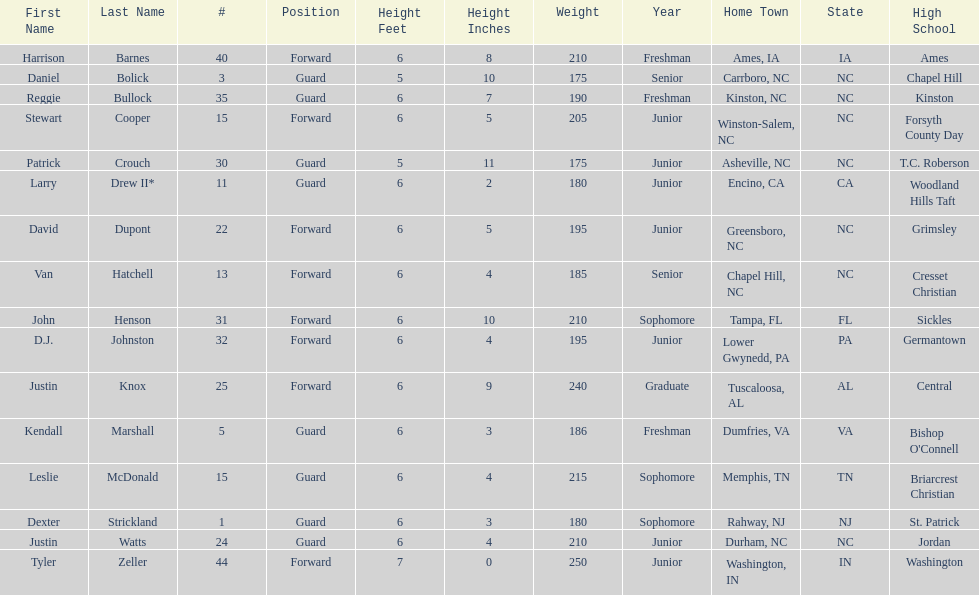How many players play a position other than guard? 8. Write the full table. {'header': ['First Name', 'Last Name', '#', 'Position', 'Height Feet', 'Height Inches', 'Weight', 'Year', 'Home Town', 'State', 'High School'], 'rows': [['Harrison', 'Barnes', '40', 'Forward', '6', '8', '210', 'Freshman', 'Ames, IA', 'IA', 'Ames'], ['Daniel', 'Bolick', '3', 'Guard', '5', '10', '175', 'Senior', 'Carrboro, NC', 'NC', 'Chapel Hill'], ['Reggie', 'Bullock', '35', 'Guard', '6', '7', '190', 'Freshman', 'Kinston, NC', 'NC', 'Kinston'], ['Stewart', 'Cooper', '15', 'Forward', '6', '5', '205', 'Junior', 'Winston-Salem, NC', 'NC', 'Forsyth County Day'], ['Patrick', 'Crouch', '30', 'Guard', '5', '11', '175', 'Junior', 'Asheville, NC', 'NC', 'T.C. Roberson'], ['Larry', 'Drew II*', '11', 'Guard', '6', '2', '180', 'Junior', 'Encino, CA', 'CA', 'Woodland Hills Taft'], ['David', 'Dupont', '22', 'Forward', '6', '5', '195', 'Junior', 'Greensboro, NC', 'NC', 'Grimsley'], ['Van', 'Hatchell', '13', 'Forward', '6', '4', '185', 'Senior', 'Chapel Hill, NC', 'NC', 'Cresset Christian'], ['John', 'Henson', '31', 'Forward', '6', '10', '210', 'Sophomore', 'Tampa, FL', 'FL', 'Sickles'], ['D.J.', 'Johnston', '32', 'Forward', '6', '4', '195', 'Junior', 'Lower Gwynedd, PA', 'PA', 'Germantown'], ['Justin', 'Knox', '25', 'Forward', '6', '9', '240', 'Graduate', 'Tuscaloosa, AL', 'AL', 'Central'], ['Kendall', 'Marshall', '5', 'Guard', '6', '3', '186', 'Freshman', 'Dumfries, VA', 'VA', "Bishop O'Connell"], ['Leslie', 'McDonald', '15', 'Guard', '6', '4', '215', 'Sophomore', 'Memphis, TN', 'TN', 'Briarcrest Christian'], ['Dexter', 'Strickland', '1', 'Guard', '6', '3', '180', 'Sophomore', 'Rahway, NJ', 'NJ', 'St. Patrick'], ['Justin', 'Watts', '24', 'Guard', '6', '4', '210', 'Junior', 'Durham, NC', 'NC', 'Jordan'], ['Tyler', 'Zeller', '44', 'Forward', '7', '0', '250', 'Junior', 'Washington, IN', 'IN', 'Washington']]} 